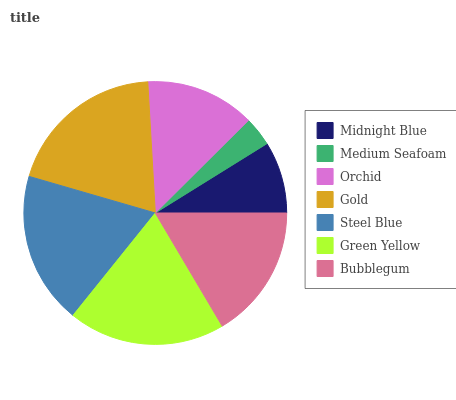Is Medium Seafoam the minimum?
Answer yes or no. Yes. Is Gold the maximum?
Answer yes or no. Yes. Is Orchid the minimum?
Answer yes or no. No. Is Orchid the maximum?
Answer yes or no. No. Is Orchid greater than Medium Seafoam?
Answer yes or no. Yes. Is Medium Seafoam less than Orchid?
Answer yes or no. Yes. Is Medium Seafoam greater than Orchid?
Answer yes or no. No. Is Orchid less than Medium Seafoam?
Answer yes or no. No. Is Bubblegum the high median?
Answer yes or no. Yes. Is Bubblegum the low median?
Answer yes or no. Yes. Is Midnight Blue the high median?
Answer yes or no. No. Is Green Yellow the low median?
Answer yes or no. No. 